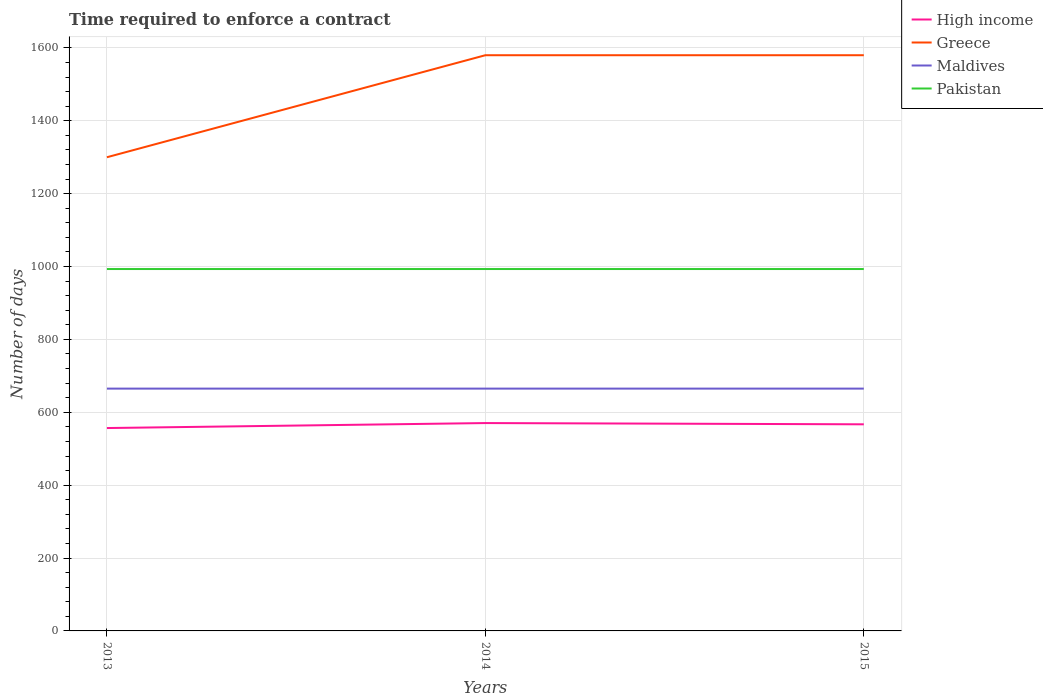Across all years, what is the maximum number of days required to enforce a contract in Maldives?
Make the answer very short. 665. What is the difference between the highest and the second highest number of days required to enforce a contract in High income?
Provide a succinct answer. 13.67. What is the difference between the highest and the lowest number of days required to enforce a contract in Maldives?
Make the answer very short. 0. How many lines are there?
Your response must be concise. 4. How many years are there in the graph?
Ensure brevity in your answer.  3. What is the difference between two consecutive major ticks on the Y-axis?
Provide a succinct answer. 200. Are the values on the major ticks of Y-axis written in scientific E-notation?
Provide a succinct answer. No. How many legend labels are there?
Give a very brief answer. 4. How are the legend labels stacked?
Offer a terse response. Vertical. What is the title of the graph?
Offer a very short reply. Time required to enforce a contract. What is the label or title of the X-axis?
Your response must be concise. Years. What is the label or title of the Y-axis?
Keep it short and to the point. Number of days. What is the Number of days of High income in 2013?
Keep it short and to the point. 556.78. What is the Number of days of Greece in 2013?
Your response must be concise. 1300. What is the Number of days of Maldives in 2013?
Your answer should be very brief. 665. What is the Number of days of Pakistan in 2013?
Offer a terse response. 993.2. What is the Number of days of High income in 2014?
Give a very brief answer. 570.45. What is the Number of days of Greece in 2014?
Keep it short and to the point. 1580. What is the Number of days in Maldives in 2014?
Offer a terse response. 665. What is the Number of days of Pakistan in 2014?
Provide a short and direct response. 993.2. What is the Number of days of High income in 2015?
Keep it short and to the point. 567.05. What is the Number of days of Greece in 2015?
Your answer should be very brief. 1580. What is the Number of days in Maldives in 2015?
Offer a very short reply. 665. What is the Number of days in Pakistan in 2015?
Provide a short and direct response. 993.2. Across all years, what is the maximum Number of days in High income?
Make the answer very short. 570.45. Across all years, what is the maximum Number of days in Greece?
Your response must be concise. 1580. Across all years, what is the maximum Number of days of Maldives?
Keep it short and to the point. 665. Across all years, what is the maximum Number of days in Pakistan?
Make the answer very short. 993.2. Across all years, what is the minimum Number of days in High income?
Offer a terse response. 556.78. Across all years, what is the minimum Number of days in Greece?
Make the answer very short. 1300. Across all years, what is the minimum Number of days of Maldives?
Provide a short and direct response. 665. Across all years, what is the minimum Number of days of Pakistan?
Ensure brevity in your answer.  993.2. What is the total Number of days of High income in the graph?
Your answer should be very brief. 1694.28. What is the total Number of days in Greece in the graph?
Offer a terse response. 4460. What is the total Number of days of Maldives in the graph?
Offer a terse response. 1995. What is the total Number of days in Pakistan in the graph?
Provide a short and direct response. 2979.6. What is the difference between the Number of days of High income in 2013 and that in 2014?
Provide a succinct answer. -13.67. What is the difference between the Number of days in Greece in 2013 and that in 2014?
Your answer should be very brief. -280. What is the difference between the Number of days of High income in 2013 and that in 2015?
Make the answer very short. -10.27. What is the difference between the Number of days of Greece in 2013 and that in 2015?
Offer a very short reply. -280. What is the difference between the Number of days in Pakistan in 2013 and that in 2015?
Your answer should be compact. 0. What is the difference between the Number of days in High income in 2014 and that in 2015?
Make the answer very short. 3.4. What is the difference between the Number of days in Maldives in 2014 and that in 2015?
Provide a short and direct response. 0. What is the difference between the Number of days of Pakistan in 2014 and that in 2015?
Your answer should be compact. 0. What is the difference between the Number of days in High income in 2013 and the Number of days in Greece in 2014?
Offer a very short reply. -1023.22. What is the difference between the Number of days in High income in 2013 and the Number of days in Maldives in 2014?
Give a very brief answer. -108.22. What is the difference between the Number of days in High income in 2013 and the Number of days in Pakistan in 2014?
Provide a short and direct response. -436.42. What is the difference between the Number of days in Greece in 2013 and the Number of days in Maldives in 2014?
Give a very brief answer. 635. What is the difference between the Number of days of Greece in 2013 and the Number of days of Pakistan in 2014?
Give a very brief answer. 306.8. What is the difference between the Number of days in Maldives in 2013 and the Number of days in Pakistan in 2014?
Your answer should be very brief. -328.2. What is the difference between the Number of days of High income in 2013 and the Number of days of Greece in 2015?
Offer a very short reply. -1023.22. What is the difference between the Number of days in High income in 2013 and the Number of days in Maldives in 2015?
Offer a very short reply. -108.22. What is the difference between the Number of days in High income in 2013 and the Number of days in Pakistan in 2015?
Make the answer very short. -436.42. What is the difference between the Number of days in Greece in 2013 and the Number of days in Maldives in 2015?
Your answer should be compact. 635. What is the difference between the Number of days of Greece in 2013 and the Number of days of Pakistan in 2015?
Keep it short and to the point. 306.8. What is the difference between the Number of days in Maldives in 2013 and the Number of days in Pakistan in 2015?
Your answer should be very brief. -328.2. What is the difference between the Number of days in High income in 2014 and the Number of days in Greece in 2015?
Provide a succinct answer. -1009.55. What is the difference between the Number of days of High income in 2014 and the Number of days of Maldives in 2015?
Make the answer very short. -94.55. What is the difference between the Number of days in High income in 2014 and the Number of days in Pakistan in 2015?
Your answer should be compact. -422.75. What is the difference between the Number of days of Greece in 2014 and the Number of days of Maldives in 2015?
Offer a terse response. 915. What is the difference between the Number of days in Greece in 2014 and the Number of days in Pakistan in 2015?
Make the answer very short. 586.8. What is the difference between the Number of days of Maldives in 2014 and the Number of days of Pakistan in 2015?
Your answer should be very brief. -328.2. What is the average Number of days of High income per year?
Keep it short and to the point. 564.76. What is the average Number of days in Greece per year?
Keep it short and to the point. 1486.67. What is the average Number of days in Maldives per year?
Your response must be concise. 665. What is the average Number of days of Pakistan per year?
Give a very brief answer. 993.2. In the year 2013, what is the difference between the Number of days of High income and Number of days of Greece?
Offer a very short reply. -743.22. In the year 2013, what is the difference between the Number of days in High income and Number of days in Maldives?
Make the answer very short. -108.22. In the year 2013, what is the difference between the Number of days in High income and Number of days in Pakistan?
Offer a very short reply. -436.42. In the year 2013, what is the difference between the Number of days in Greece and Number of days in Maldives?
Give a very brief answer. 635. In the year 2013, what is the difference between the Number of days in Greece and Number of days in Pakistan?
Your response must be concise. 306.8. In the year 2013, what is the difference between the Number of days in Maldives and Number of days in Pakistan?
Your answer should be compact. -328.2. In the year 2014, what is the difference between the Number of days in High income and Number of days in Greece?
Your answer should be compact. -1009.55. In the year 2014, what is the difference between the Number of days in High income and Number of days in Maldives?
Your response must be concise. -94.55. In the year 2014, what is the difference between the Number of days of High income and Number of days of Pakistan?
Provide a succinct answer. -422.75. In the year 2014, what is the difference between the Number of days in Greece and Number of days in Maldives?
Offer a very short reply. 915. In the year 2014, what is the difference between the Number of days in Greece and Number of days in Pakistan?
Ensure brevity in your answer.  586.8. In the year 2014, what is the difference between the Number of days of Maldives and Number of days of Pakistan?
Your answer should be compact. -328.2. In the year 2015, what is the difference between the Number of days of High income and Number of days of Greece?
Provide a short and direct response. -1012.95. In the year 2015, what is the difference between the Number of days in High income and Number of days in Maldives?
Ensure brevity in your answer.  -97.95. In the year 2015, what is the difference between the Number of days in High income and Number of days in Pakistan?
Provide a succinct answer. -426.15. In the year 2015, what is the difference between the Number of days of Greece and Number of days of Maldives?
Keep it short and to the point. 915. In the year 2015, what is the difference between the Number of days in Greece and Number of days in Pakistan?
Provide a succinct answer. 586.8. In the year 2015, what is the difference between the Number of days of Maldives and Number of days of Pakistan?
Provide a succinct answer. -328.2. What is the ratio of the Number of days of High income in 2013 to that in 2014?
Offer a very short reply. 0.98. What is the ratio of the Number of days in Greece in 2013 to that in 2014?
Make the answer very short. 0.82. What is the ratio of the Number of days of Maldives in 2013 to that in 2014?
Make the answer very short. 1. What is the ratio of the Number of days in High income in 2013 to that in 2015?
Your answer should be very brief. 0.98. What is the ratio of the Number of days of Greece in 2013 to that in 2015?
Offer a terse response. 0.82. What is the ratio of the Number of days of High income in 2014 to that in 2015?
Ensure brevity in your answer.  1.01. What is the ratio of the Number of days in Greece in 2014 to that in 2015?
Your answer should be very brief. 1. What is the difference between the highest and the second highest Number of days in Maldives?
Give a very brief answer. 0. What is the difference between the highest and the second highest Number of days in Pakistan?
Offer a very short reply. 0. What is the difference between the highest and the lowest Number of days in High income?
Provide a succinct answer. 13.67. What is the difference between the highest and the lowest Number of days of Greece?
Provide a succinct answer. 280. What is the difference between the highest and the lowest Number of days in Maldives?
Ensure brevity in your answer.  0. What is the difference between the highest and the lowest Number of days in Pakistan?
Your response must be concise. 0. 